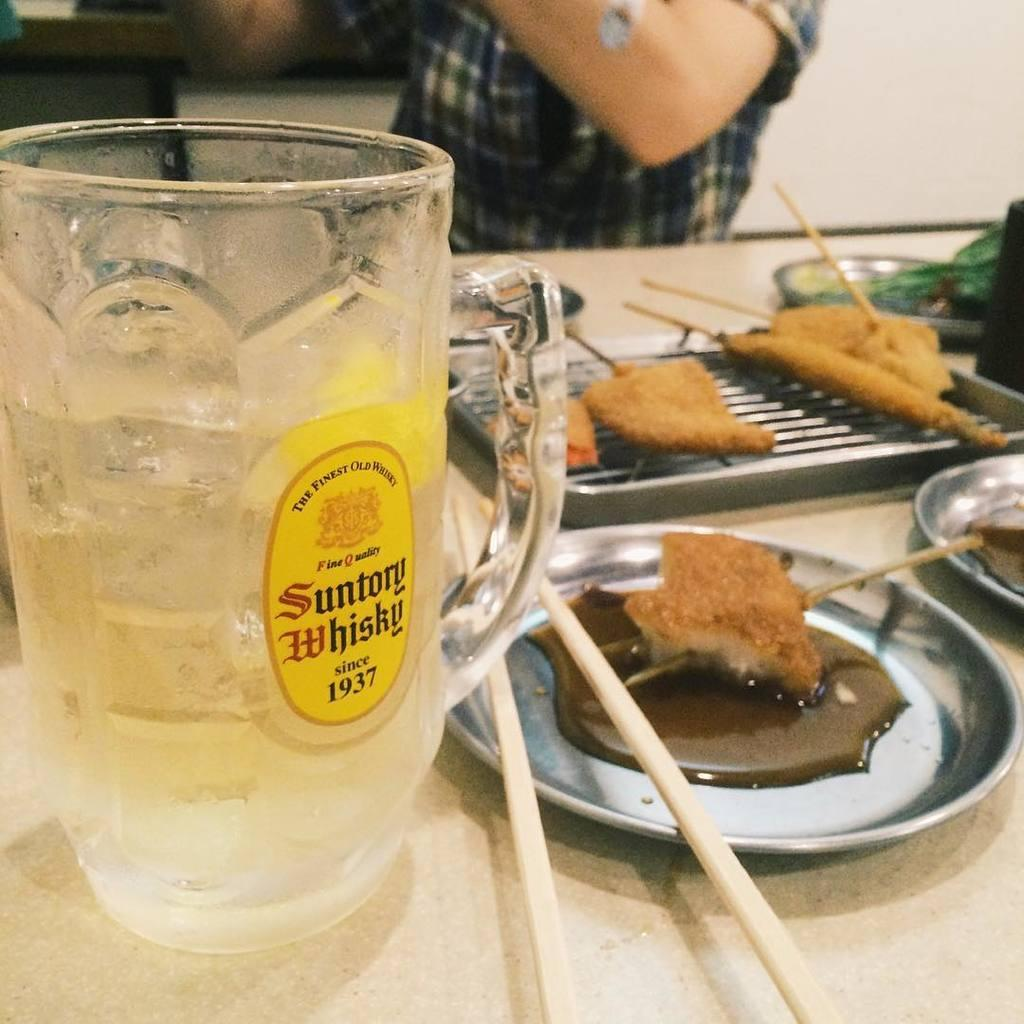What is the main object in the center of the image? There is a table in the center of the image. What can be found on the table? There is a mug, plates, a tray, chopsticks, and food on the table. Can you describe the person in the background of the image? There is no description of the person in the background of the image. What is visible in the background of the image? There is a wall in the background of the image. What type of juice is being served in the mug on the table? There is no juice present in the mug on the table; it is not mentioned in the facts provided. 